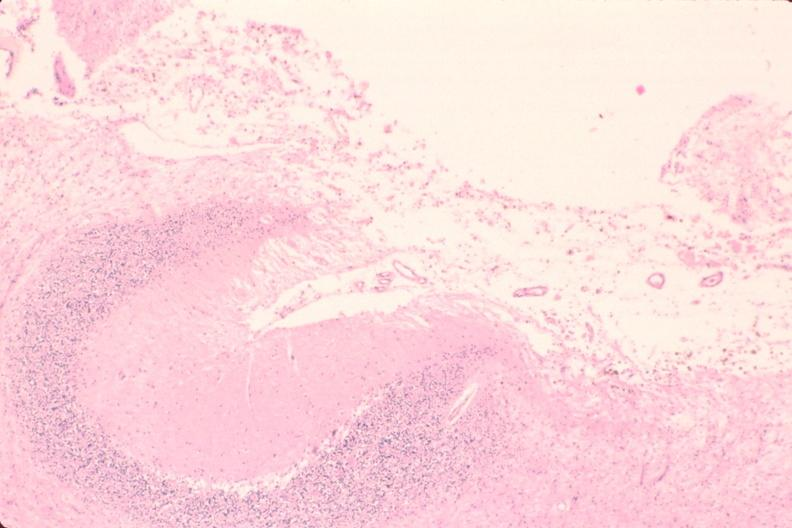where is this?
Answer the question using a single word or phrase. Nervous 